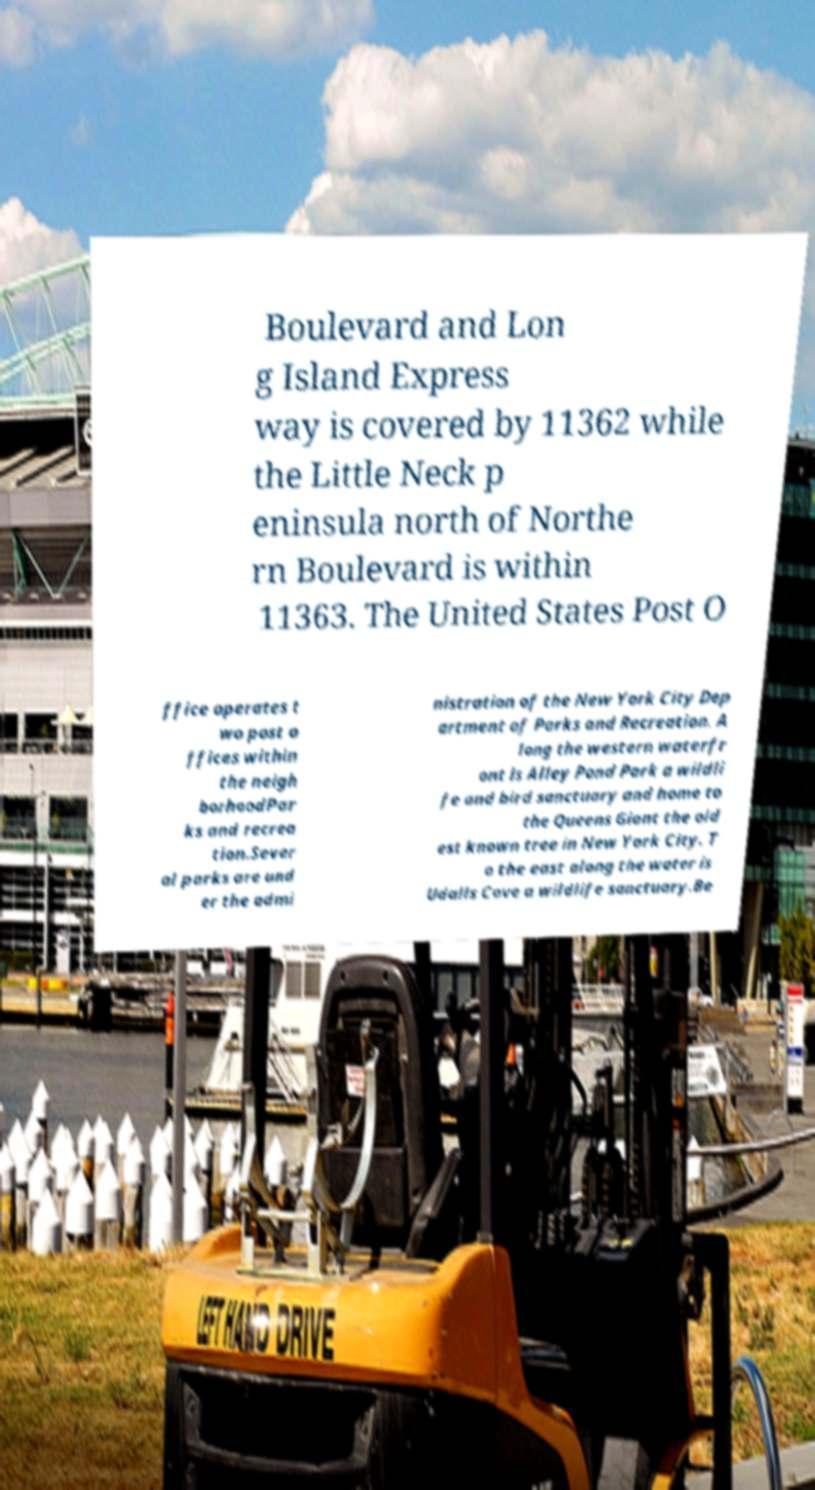What messages or text are displayed in this image? I need them in a readable, typed format. Boulevard and Lon g Island Express way is covered by 11362 while the Little Neck p eninsula north of Northe rn Boulevard is within 11363. The United States Post O ffice operates t wo post o ffices within the neigh borhoodPar ks and recrea tion.Sever al parks are und er the admi nistration of the New York City Dep artment of Parks and Recreation. A long the western waterfr ont is Alley Pond Park a wildli fe and bird sanctuary and home to the Queens Giant the old est known tree in New York City. T o the east along the water is Udalls Cove a wildlife sanctuary.Be 